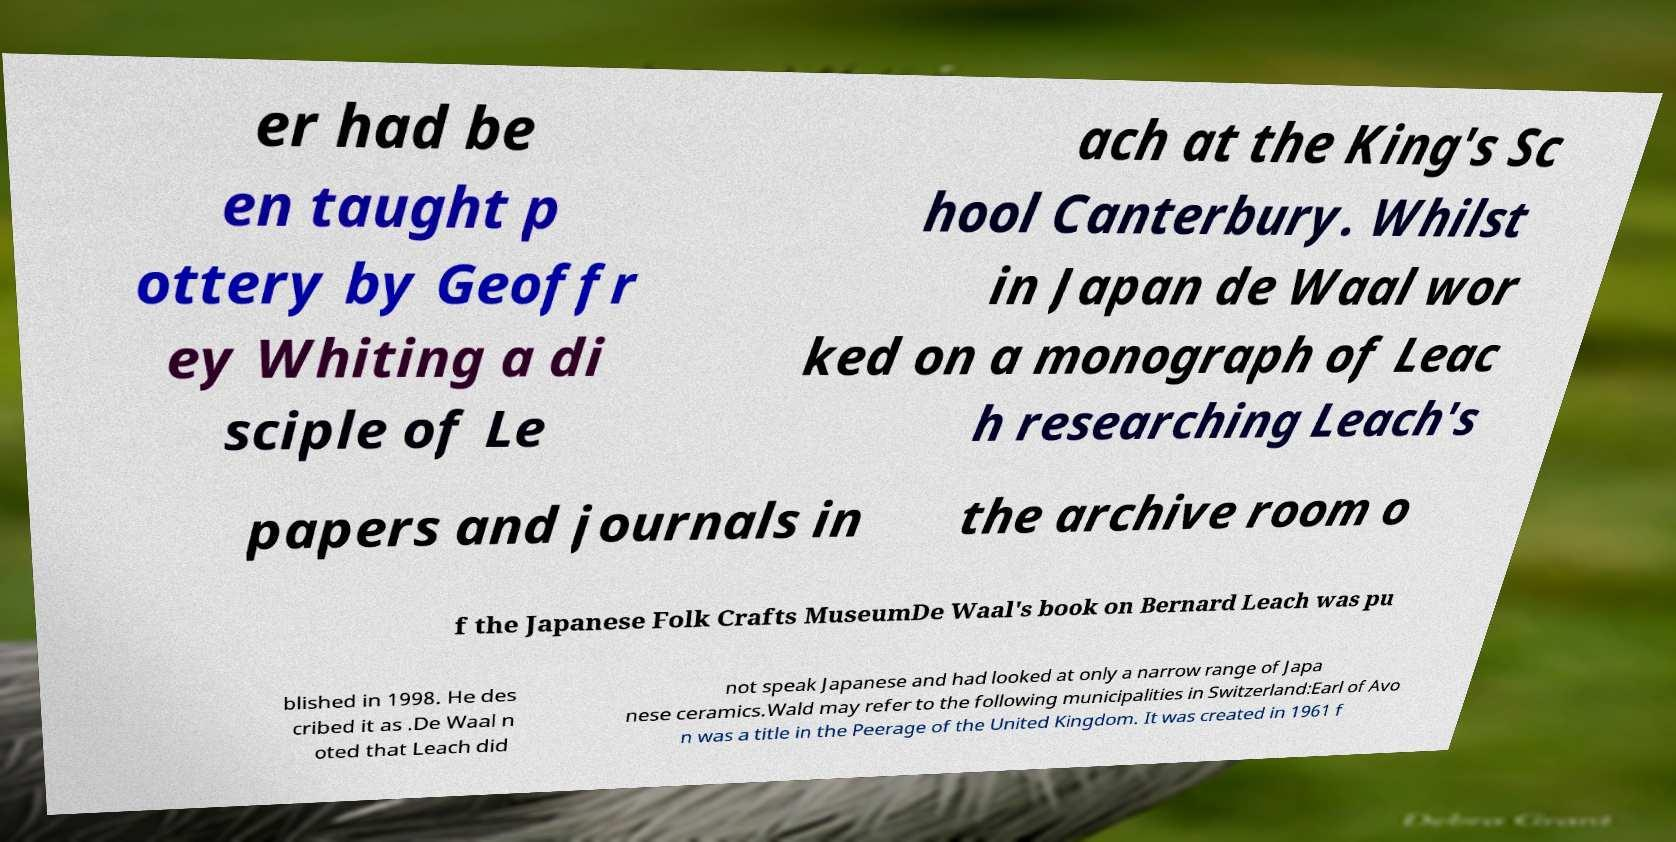Please identify and transcribe the text found in this image. er had be en taught p ottery by Geoffr ey Whiting a di sciple of Le ach at the King's Sc hool Canterbury. Whilst in Japan de Waal wor ked on a monograph of Leac h researching Leach's papers and journals in the archive room o f the Japanese Folk Crafts MuseumDe Waal's book on Bernard Leach was pu blished in 1998. He des cribed it as .De Waal n oted that Leach did not speak Japanese and had looked at only a narrow range of Japa nese ceramics.Wald may refer to the following municipalities in Switzerland:Earl of Avo n was a title in the Peerage of the United Kingdom. It was created in 1961 f 